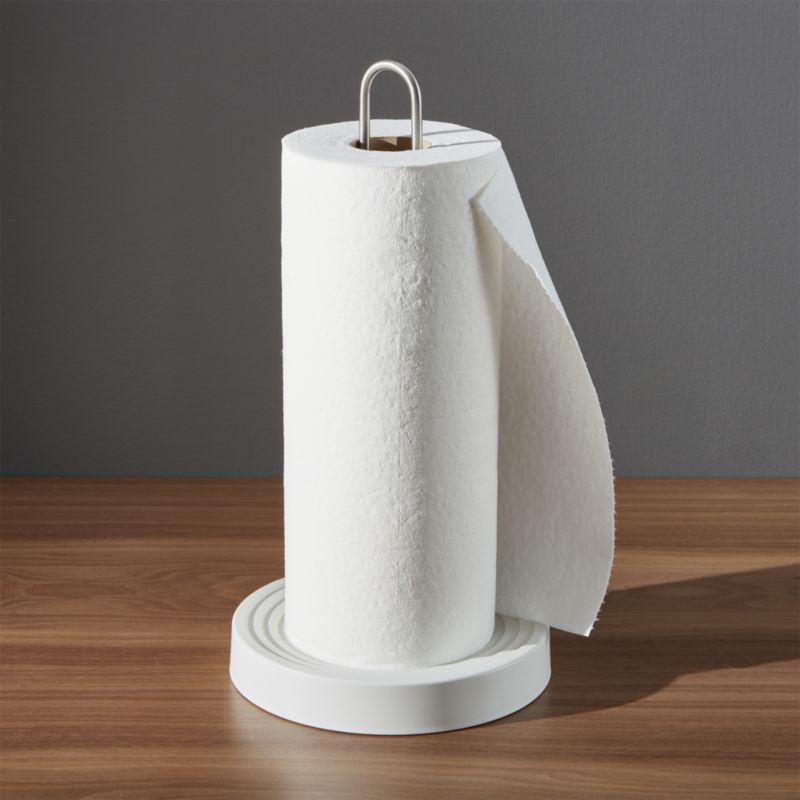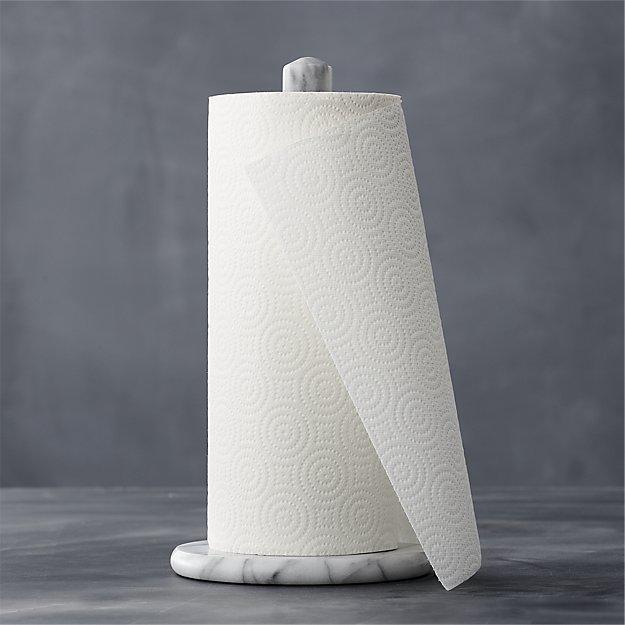The first image is the image on the left, the second image is the image on the right. Examine the images to the left and right. Is the description "There is at least one paper towel roll hanging" accurate? Answer yes or no. No. The first image is the image on the left, the second image is the image on the right. For the images shown, is this caption "A roll of paper towels is on a rack under a cabinet with the next towel hanging from the back." true? Answer yes or no. No. 